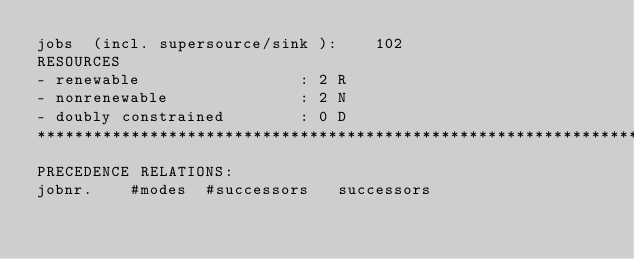<code> <loc_0><loc_0><loc_500><loc_500><_ObjectiveC_>jobs  (incl. supersource/sink ):	102
RESOURCES
- renewable                 : 2 R
- nonrenewable              : 2 N
- doubly constrained        : 0 D
************************************************************************
PRECEDENCE RELATIONS:
jobnr.    #modes  #successors   successors</code> 